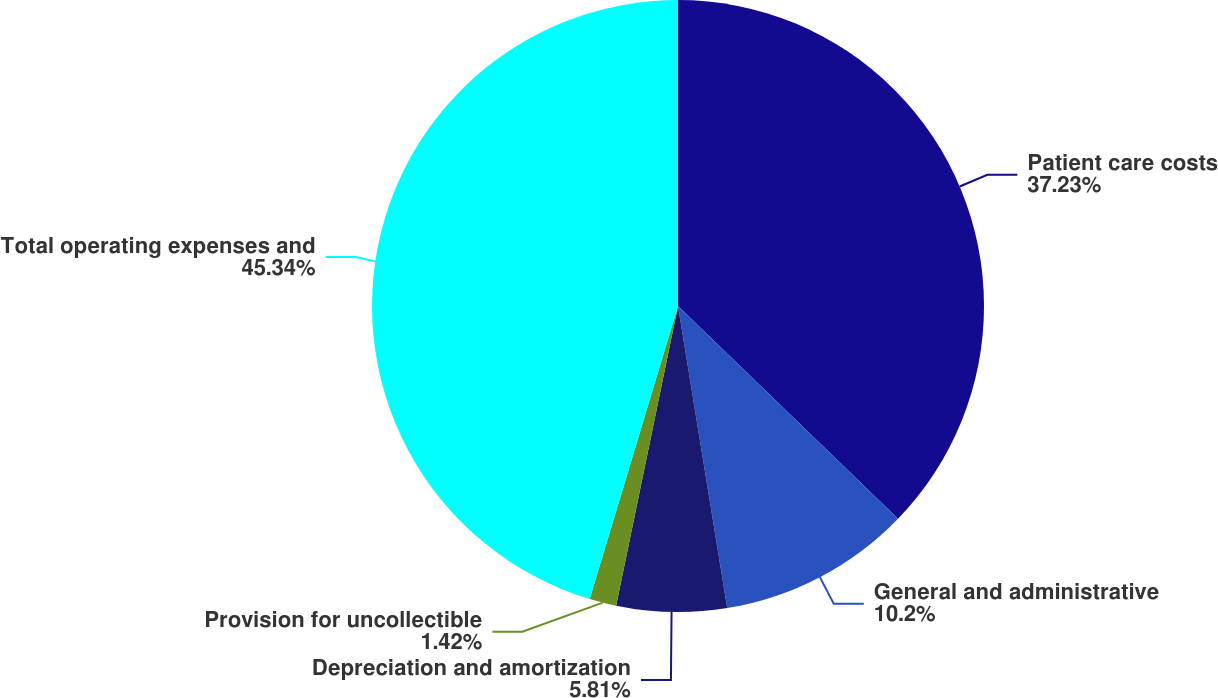Convert chart. <chart><loc_0><loc_0><loc_500><loc_500><pie_chart><fcel>Patient care costs<fcel>General and administrative<fcel>Depreciation and amortization<fcel>Provision for uncollectible<fcel>Total operating expenses and<nl><fcel>37.22%<fcel>10.2%<fcel>5.81%<fcel>1.42%<fcel>45.33%<nl></chart> 